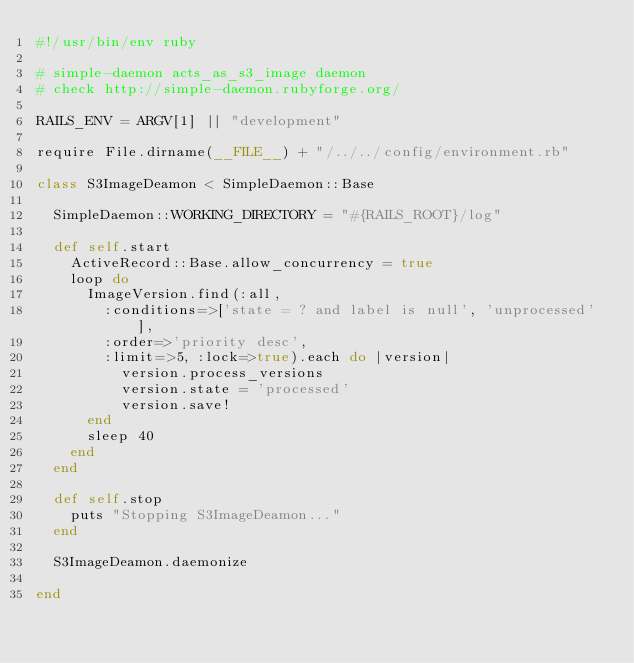<code> <loc_0><loc_0><loc_500><loc_500><_Ruby_>#!/usr/bin/env ruby

# simple-daemon acts_as_s3_image daemon
# check http://simple-daemon.rubyforge.org/

RAILS_ENV = ARGV[1] || "development"

require File.dirname(__FILE__) + "/../../config/environment.rb"

class S3ImageDeamon < SimpleDaemon::Base
  
  SimpleDaemon::WORKING_DIRECTORY = "#{RAILS_ROOT}/log"
  
  def self.start
    ActiveRecord::Base.allow_concurrency = true
    loop do
      ImageVersion.find(:all, 
        :conditions=>['state = ? and label is null', 'unprocessed'], 
        :order=>'priority desc',
        :limit=>5, :lock=>true).each do |version|
          version.process_versions
          version.state = 'processed'
          version.save!
      end
      sleep 40
    end
  end
  
  def self.stop
    puts "Stopping S3ImageDeamon..."
  end
  
  S3ImageDeamon.daemonize
  
end

</code> 